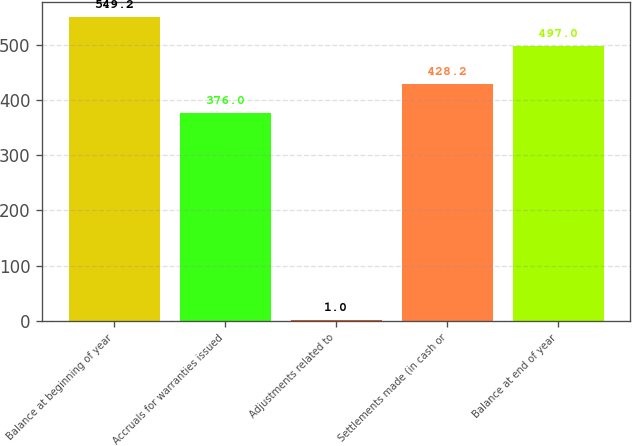Convert chart. <chart><loc_0><loc_0><loc_500><loc_500><bar_chart><fcel>Balance at beginning of year<fcel>Accruals for warranties issued<fcel>Adjustments related to<fcel>Settlements made (in cash or<fcel>Balance at end of year<nl><fcel>549.2<fcel>376<fcel>1<fcel>428.2<fcel>497<nl></chart> 